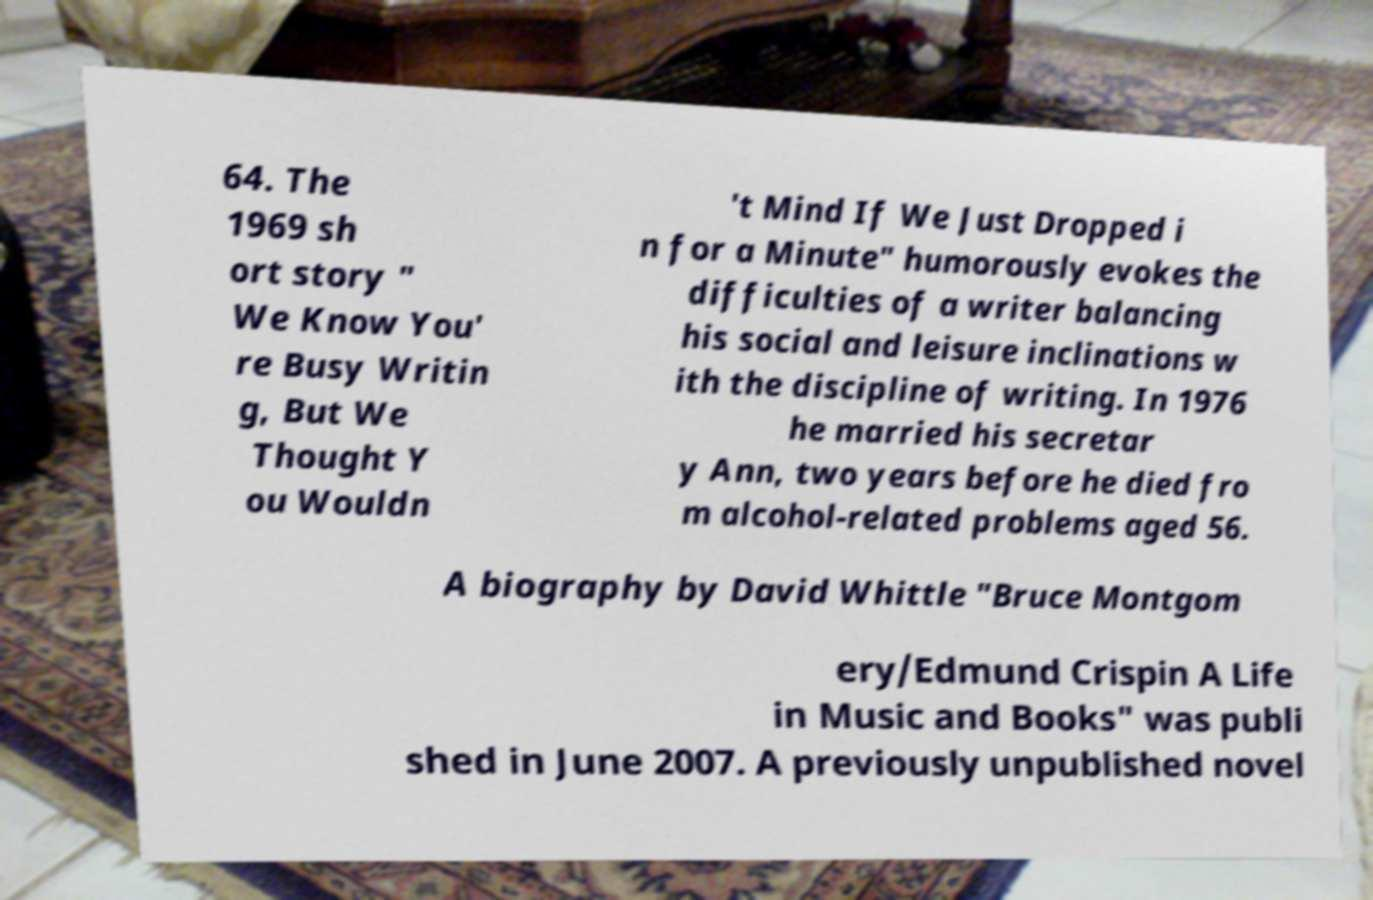Please identify and transcribe the text found in this image. 64. The 1969 sh ort story " We Know You' re Busy Writin g, But We Thought Y ou Wouldn 't Mind If We Just Dropped i n for a Minute" humorously evokes the difficulties of a writer balancing his social and leisure inclinations w ith the discipline of writing. In 1976 he married his secretar y Ann, two years before he died fro m alcohol-related problems aged 56. A biography by David Whittle "Bruce Montgom ery/Edmund Crispin A Life in Music and Books" was publi shed in June 2007. A previously unpublished novel 